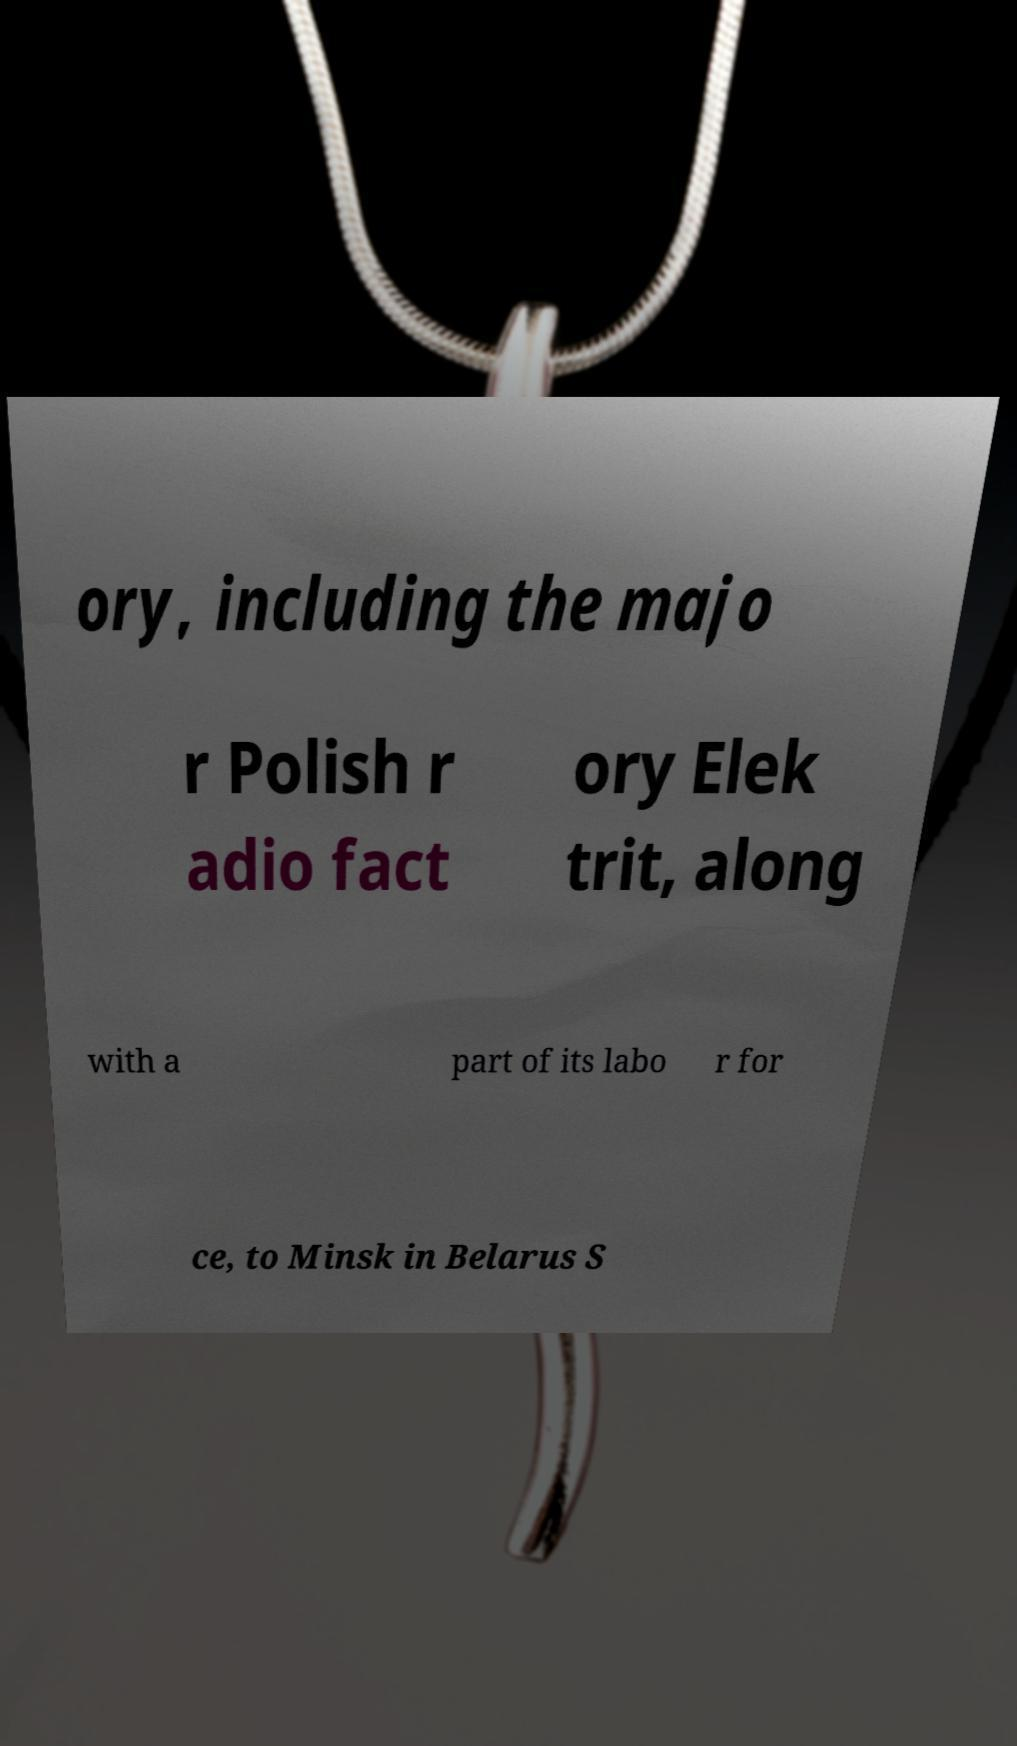There's text embedded in this image that I need extracted. Can you transcribe it verbatim? ory, including the majo r Polish r adio fact ory Elek trit, along with a part of its labo r for ce, to Minsk in Belarus S 